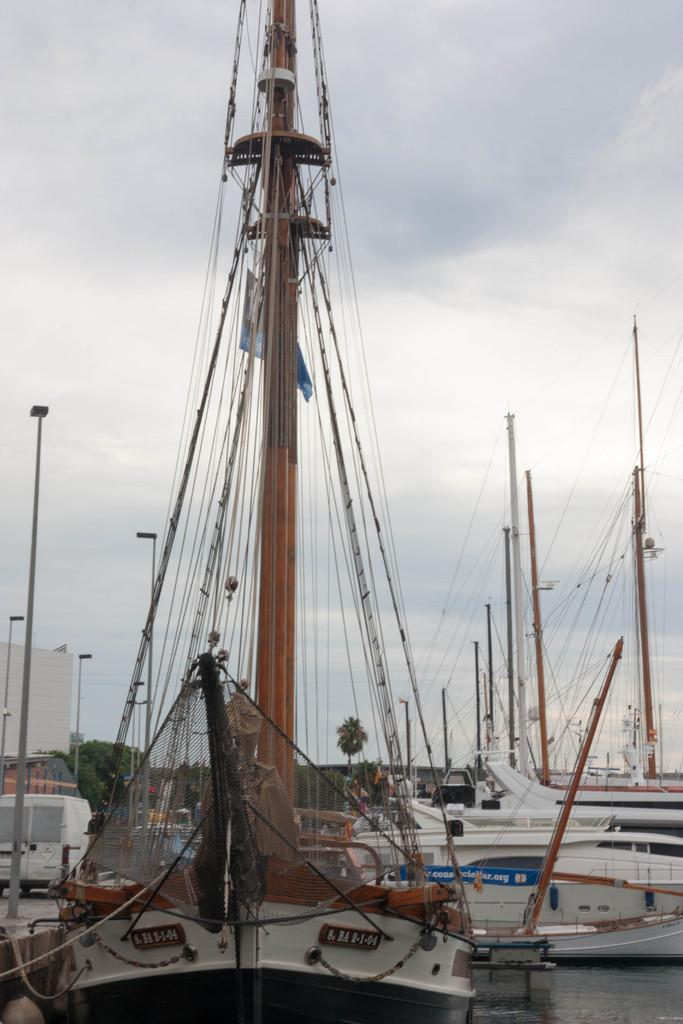What is on the water in the image? There are boats on the water in the image. What type of natural environment is visible in the image? There are trees visible in the image. What is on the ground in the image? There is a vehicle on the ground in the image. What is visible in the background of the image? The sky is visible in the background of the image. Where is the ornament located in the image? There is no ornament present in the image. How many seats are visible in the image? The image does not show any seats, so it is not possible to determine the number of seats. 